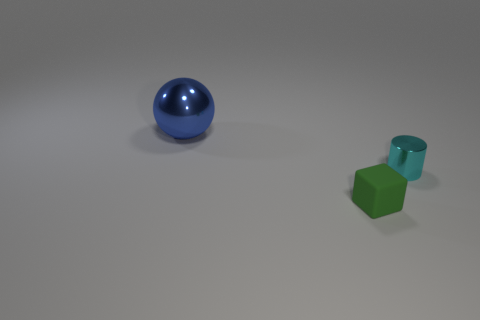How many other things are there of the same size as the cyan shiny thing?
Ensure brevity in your answer.  1. Is there any other thing that has the same shape as the tiny cyan metallic thing?
Your answer should be very brief. No. What is the color of the ball that is the same material as the cyan object?
Give a very brief answer. Blue. What number of objects are tiny yellow matte balls or metallic objects?
Your answer should be compact. 2. Does the green matte cube have the same size as the shiny object right of the metallic ball?
Provide a short and direct response. Yes. There is a tiny object behind the rubber block on the left side of the tiny thing that is behind the rubber cube; what is its color?
Ensure brevity in your answer.  Cyan. The large shiny sphere is what color?
Offer a terse response. Blue. Is the number of green matte cubes that are left of the small green block greater than the number of rubber objects that are behind the tiny cyan shiny object?
Ensure brevity in your answer.  No. Is the shape of the big blue thing the same as the small object that is in front of the cyan metal cylinder?
Your response must be concise. No. Does the thing on the left side of the green block have the same size as the cyan object behind the small rubber cube?
Your response must be concise. No. 